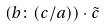<formula> <loc_0><loc_0><loc_500><loc_500>( b \colon ( c / a ) ) \cdot \tilde { c }</formula> 